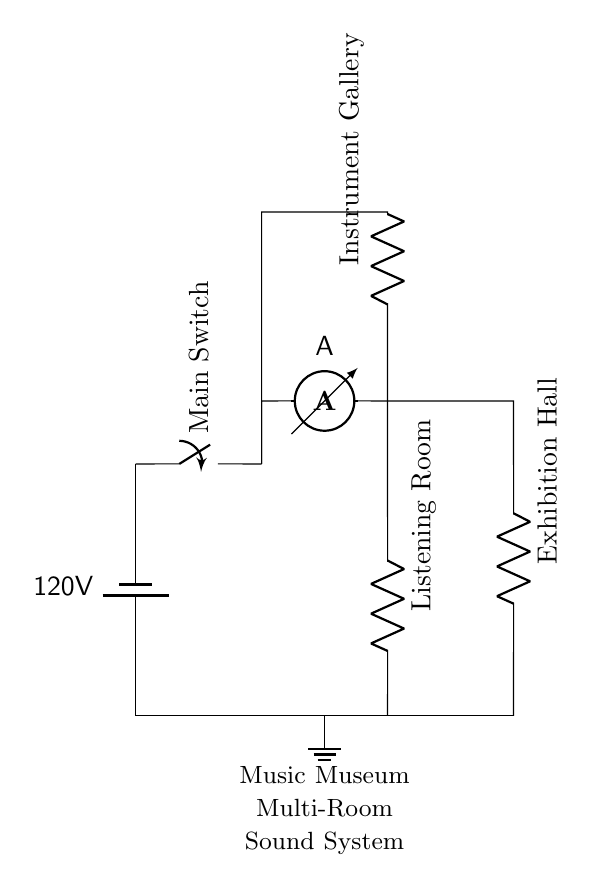What is the voltage of this circuit? The voltage is 120V, which is indicated by the labeled battery symbol. It represents the electrical potential available in the entire circuit.
Answer: 120V What components are connected in parallel? The components connected in parallel are the resistors labeled "Exhibition Hall," "Listening Room," and "Instrument Gallery." This can be identified by observing that they branch off from the same node.
Answer: Exhibition Hall, Listening Room, Instrument Gallery How many resistors are in this circuit? There are three resistors, corresponding to the three parallel connections for the different rooms in the museum. Each room has its own dedicated resistor as depicted in the diagram.
Answer: 3 What does the ammeter measure in this circuit? The ammeter measures the total current flowing through the circuit. It is positioned in a way that captures the current from the main branch before it splits into the parallel branches.
Answer: Total current How does the parallel configuration affect the voltage across each room? In a parallel circuit, the voltage across each connected component is the same as the supply voltage. Therefore, each room experiences the same voltage of 120V due to the parallel arrangement.
Answer: 120V Which room would be affected if one resistor fails? If one resistor fails, only the corresponding room would be affected, while the other rooms would continue to operate normally. This highlights the advantage of a parallel circuit, where failure of one path does not interrupt the flow in others.
Answer: Corresponding room 